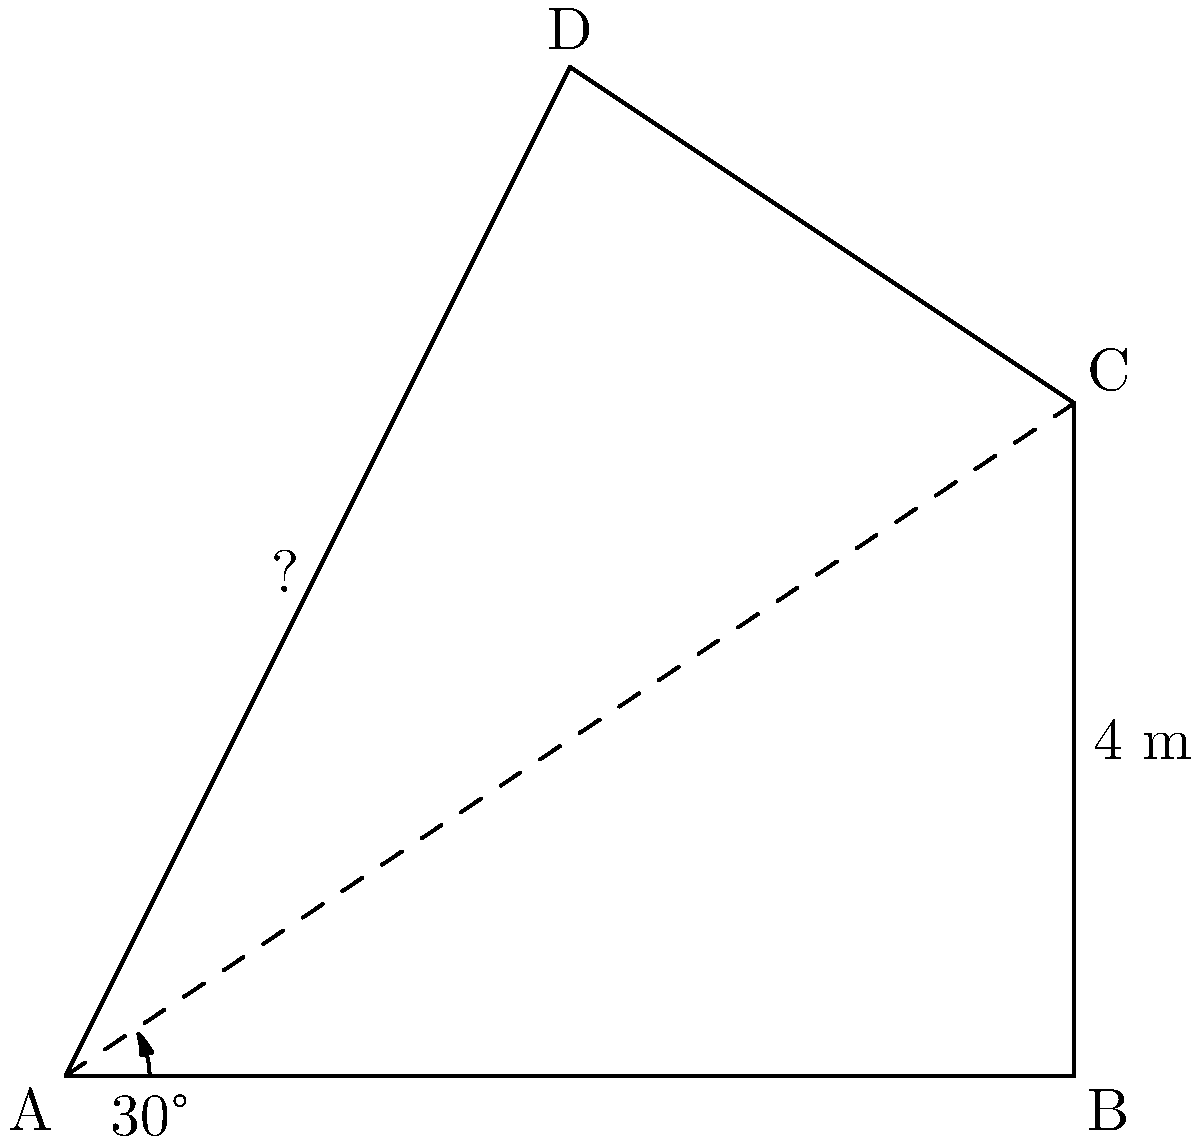In a surrealist landscape inspired by Salvador Dali, you encounter a melting building resembling a distorted triangle. The base of the building (AB) measures 6 meters, and the right side (BC) is 4 meters tall. The left side (AD) of the building forms a 30° angle with the ground. Using trigonometric ratios, calculate the height of the building's highest point (D) from the ground. To solve this problem, we'll use the trigonometric ratio tangent (tan) in the right triangle ABD:

1) In the right triangle ABD:
   tan(30°) = height of D / length of AB
   
2) We know that tan(30°) = $\frac{1}{\sqrt{3}}$ and AB = 6 meters

3) Let's call the height of D as h:
   $\frac{1}{\sqrt{3}} = \frac{h}{6}$

4) Cross multiply:
   $h = 6 \cdot \frac{1}{\sqrt{3}}$

5) Simplify:
   $h = \frac{6}{\sqrt{3}} = \frac{6\sqrt{3}}{3} = 2\sqrt{3}$

6) To get a decimal approximation:
   $h \approx 2 \cdot 1.732 \approx 3.464$ meters

Thus, the height of the highest point D is $2\sqrt{3}$ meters or approximately 3.464 meters.
Answer: $2\sqrt{3}$ meters 